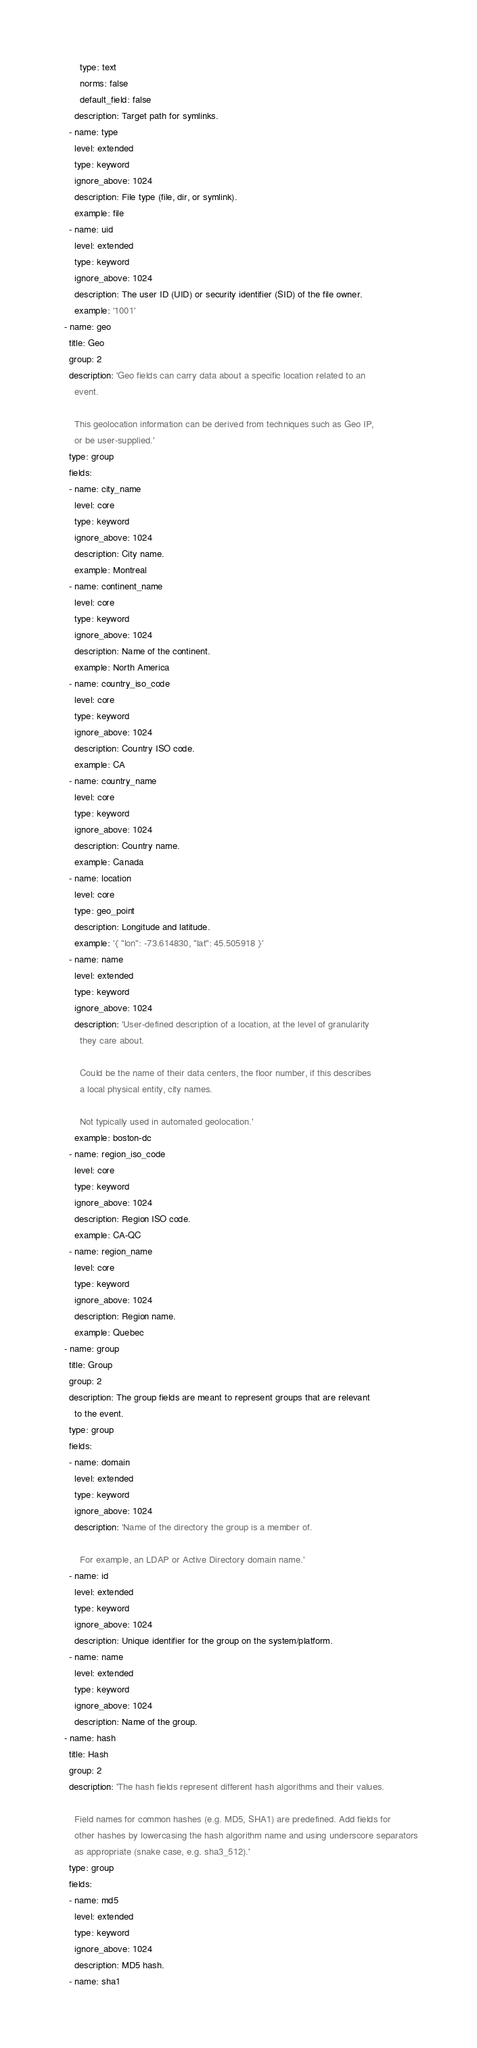Convert code to text. <code><loc_0><loc_0><loc_500><loc_500><_YAML_>        type: text
        norms: false
        default_field: false
      description: Target path for symlinks.
    - name: type
      level: extended
      type: keyword
      ignore_above: 1024
      description: File type (file, dir, or symlink).
      example: file
    - name: uid
      level: extended
      type: keyword
      ignore_above: 1024
      description: The user ID (UID) or security identifier (SID) of the file owner.
      example: '1001'
  - name: geo
    title: Geo
    group: 2
    description: 'Geo fields can carry data about a specific location related to an
      event.

      This geolocation information can be derived from techniques such as Geo IP,
      or be user-supplied.'
    type: group
    fields:
    - name: city_name
      level: core
      type: keyword
      ignore_above: 1024
      description: City name.
      example: Montreal
    - name: continent_name
      level: core
      type: keyword
      ignore_above: 1024
      description: Name of the continent.
      example: North America
    - name: country_iso_code
      level: core
      type: keyword
      ignore_above: 1024
      description: Country ISO code.
      example: CA
    - name: country_name
      level: core
      type: keyword
      ignore_above: 1024
      description: Country name.
      example: Canada
    - name: location
      level: core
      type: geo_point
      description: Longitude and latitude.
      example: '{ "lon": -73.614830, "lat": 45.505918 }'
    - name: name
      level: extended
      type: keyword
      ignore_above: 1024
      description: 'User-defined description of a location, at the level of granularity
        they care about.

        Could be the name of their data centers, the floor number, if this describes
        a local physical entity, city names.

        Not typically used in automated geolocation.'
      example: boston-dc
    - name: region_iso_code
      level: core
      type: keyword
      ignore_above: 1024
      description: Region ISO code.
      example: CA-QC
    - name: region_name
      level: core
      type: keyword
      ignore_above: 1024
      description: Region name.
      example: Quebec
  - name: group
    title: Group
    group: 2
    description: The group fields are meant to represent groups that are relevant
      to the event.
    type: group
    fields:
    - name: domain
      level: extended
      type: keyword
      ignore_above: 1024
      description: 'Name of the directory the group is a member of.

        For example, an LDAP or Active Directory domain name.'
    - name: id
      level: extended
      type: keyword
      ignore_above: 1024
      description: Unique identifier for the group on the system/platform.
    - name: name
      level: extended
      type: keyword
      ignore_above: 1024
      description: Name of the group.
  - name: hash
    title: Hash
    group: 2
    description: 'The hash fields represent different hash algorithms and their values.

      Field names for common hashes (e.g. MD5, SHA1) are predefined. Add fields for
      other hashes by lowercasing the hash algorithm name and using underscore separators
      as appropriate (snake case, e.g. sha3_512).'
    type: group
    fields:
    - name: md5
      level: extended
      type: keyword
      ignore_above: 1024
      description: MD5 hash.
    - name: sha1</code> 